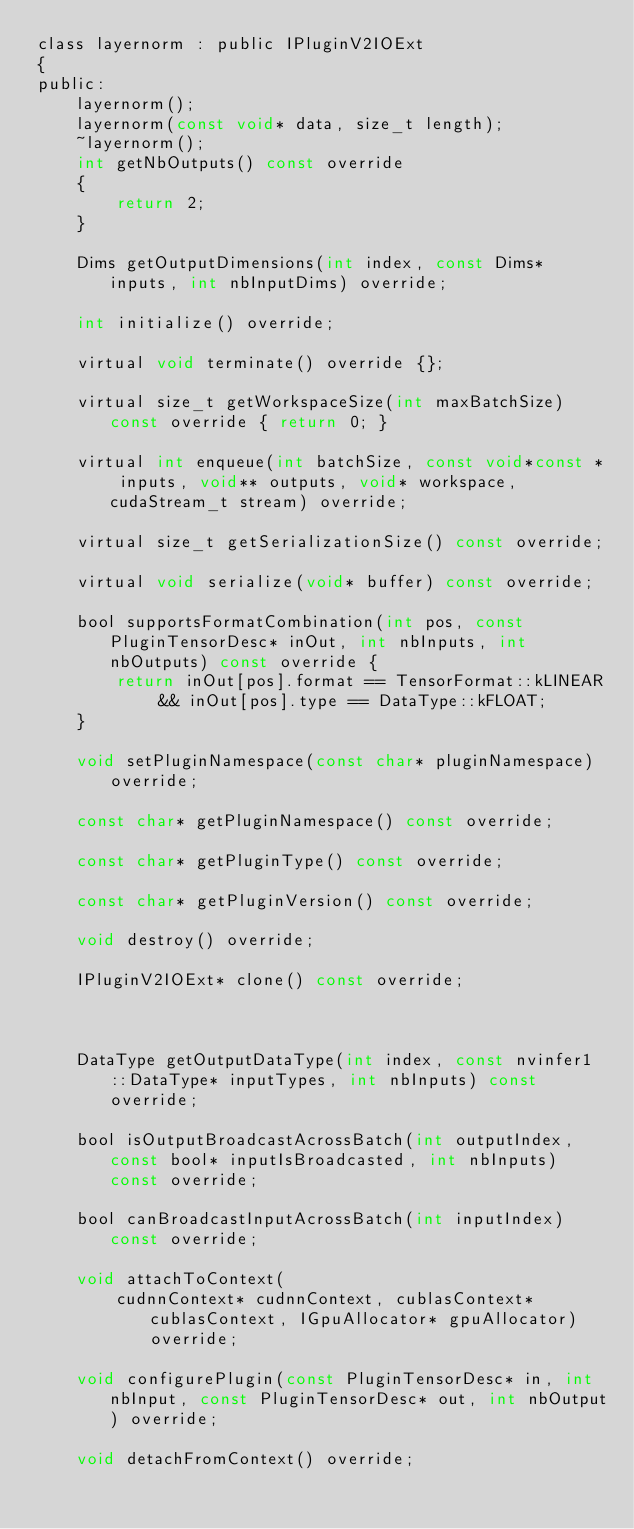Convert code to text. <code><loc_0><loc_0><loc_500><loc_500><_C_>class layernorm : public IPluginV2IOExt
{
public:
    layernorm();
    layernorm(const void* data, size_t length);
    ~layernorm();
    int getNbOutputs() const override
    {
        return 2;
    }

    Dims getOutputDimensions(int index, const Dims* inputs, int nbInputDims) override;

    int initialize() override;

    virtual void terminate() override {};

    virtual size_t getWorkspaceSize(int maxBatchSize) const override { return 0; }

    virtual int enqueue(int batchSize, const void*const * inputs, void** outputs, void* workspace, cudaStream_t stream) override;

    virtual size_t getSerializationSize() const override;

    virtual void serialize(void* buffer) const override;

    bool supportsFormatCombination(int pos, const PluginTensorDesc* inOut, int nbInputs, int nbOutputs) const override {
        return inOut[pos].format == TensorFormat::kLINEAR && inOut[pos].type == DataType::kFLOAT;
    }

    void setPluginNamespace(const char* pluginNamespace) override;

    const char* getPluginNamespace() const override;

    const char* getPluginType() const override;

    const char* getPluginVersion() const override;

    void destroy() override;

    IPluginV2IOExt* clone() const override;



    DataType getOutputDataType(int index, const nvinfer1::DataType* inputTypes, int nbInputs) const override;

    bool isOutputBroadcastAcrossBatch(int outputIndex, const bool* inputIsBroadcasted, int nbInputs) const override;

    bool canBroadcastInputAcrossBatch(int inputIndex) const override;

    void attachToContext(
        cudnnContext* cudnnContext, cublasContext* cublasContext, IGpuAllocator* gpuAllocator) override;

    void configurePlugin(const PluginTensorDesc* in, int nbInput, const PluginTensorDesc* out, int nbOutput) override;

    void detachFromContext() override;
</code> 